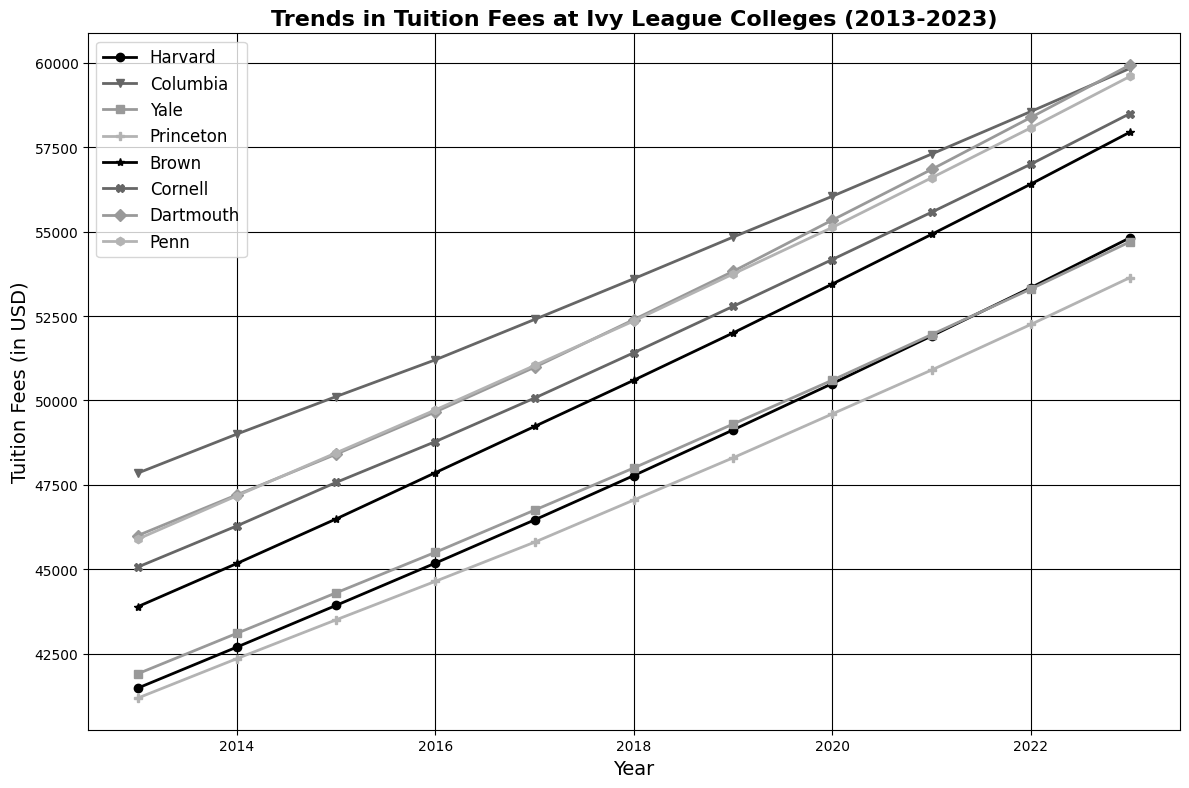What year did Harvard, Columbia, and Yale have the closest tuition fees? Harvard, Columbia, and Yale's tuition fees are closest in 2013: Harvard ($41,475), Columbia ($47,846), and Yale ($41,900). The differences between their values are one of the smallest across the years.
Answer: 2013 Which college had the highest tuition fee in 2023? Check the tuition fees for each college in 2023. Columbia has the highest with $59,840.
Answer: Columbia What's the difference in Princeton's tuition fees between 2013 and 2023? Subtract Princeton's 2013 tuition fee ($41,180) from its 2023 tuition fee ($53,640): $53,640 - $41,180 = $12,460.
Answer: $12,460 Which college had the smallest increase in tuition fees from 2013 to 2023? Calculate the difference in tuition fees for each college between 2013 and 2023. Princeton had the smallest increase from $41,180 to $53,640, an increase of $12,460.
Answer: Princeton On which year did Penn's tuition fees first exceed $50,000? Evaluate Penn's tuition fees each year to determine when it first exceeded $50,000. 2023 has Penn's fees at $51,036, which is the first year it exceeded the $50,000 mark.
Answer: 2017 What is the average tuition fee for Cornell between 2013 and 2023? Sum all the annual tuition fees for Cornell (45062 + 46284 + 47572 + 48781 + 50071 + 51415 + 52788 + 54176 + 55576 + 57000 + 58500) = 566625, then divide by 11 (years), 566625 / 11 ≈ 51420.
Answer: $51,420 Which college had the steepest increase in tuition fees from 2013 to 2023? Calculate the increase in tuition fees for each college from 2013 to 2023 and compare them. Columbia had the steepest increase from $47,846 to $59,840, an increase of $11,994.
Answer: Columbia Did any college have a decrease in tuition fees from one year to the next? Review the year-over-year tuition fee data. All colleges show an increase in tuition fees every year, so no college had a decrease.
Answer: No In which year did Harvard's tuition fee first surpass $50,000? Analyze Harvard's tuition fees year by year. In 2020, tuition first surpassed $50,000 with a fee of $50,500.
Answer: 2020 